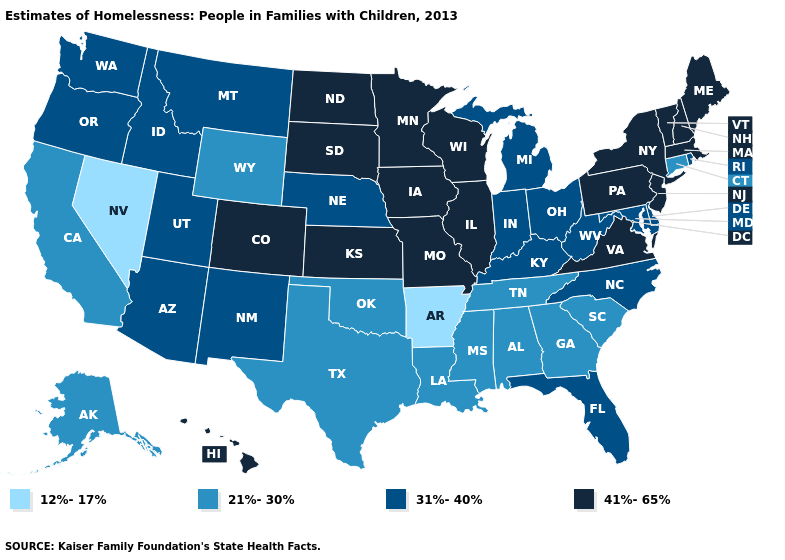Among the states that border Oklahoma , does Arkansas have the lowest value?
Concise answer only. Yes. What is the value of Idaho?
Write a very short answer. 31%-40%. What is the highest value in the Northeast ?
Write a very short answer. 41%-65%. Among the states that border West Virginia , does Pennsylvania have the highest value?
Answer briefly. Yes. Name the states that have a value in the range 41%-65%?
Give a very brief answer. Colorado, Hawaii, Illinois, Iowa, Kansas, Maine, Massachusetts, Minnesota, Missouri, New Hampshire, New Jersey, New York, North Dakota, Pennsylvania, South Dakota, Vermont, Virginia, Wisconsin. Does Kansas have the lowest value in the MidWest?
Quick response, please. No. What is the lowest value in the USA?
Be succinct. 12%-17%. Does Tennessee have a higher value than Nevada?
Short answer required. Yes. Name the states that have a value in the range 12%-17%?
Keep it brief. Arkansas, Nevada. Does the first symbol in the legend represent the smallest category?
Quick response, please. Yes. Name the states that have a value in the range 41%-65%?
Be succinct. Colorado, Hawaii, Illinois, Iowa, Kansas, Maine, Massachusetts, Minnesota, Missouri, New Hampshire, New Jersey, New York, North Dakota, Pennsylvania, South Dakota, Vermont, Virginia, Wisconsin. Does the map have missing data?
Write a very short answer. No. What is the value of New Hampshire?
Answer briefly. 41%-65%. Does North Dakota have a higher value than Kentucky?
Short answer required. Yes. What is the value of Alabama?
Keep it brief. 21%-30%. 